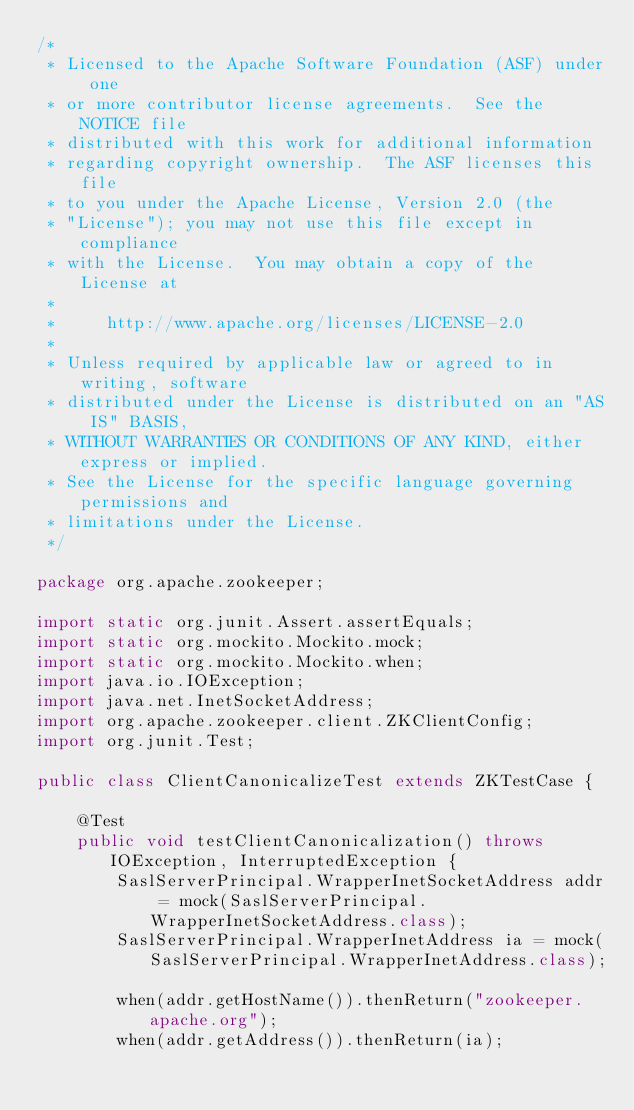Convert code to text. <code><loc_0><loc_0><loc_500><loc_500><_Java_>/*
 * Licensed to the Apache Software Foundation (ASF) under one
 * or more contributor license agreements.  See the NOTICE file
 * distributed with this work for additional information
 * regarding copyright ownership.  The ASF licenses this file
 * to you under the Apache License, Version 2.0 (the
 * "License"); you may not use this file except in compliance
 * with the License.  You may obtain a copy of the License at
 *
 *     http://www.apache.org/licenses/LICENSE-2.0
 *
 * Unless required by applicable law or agreed to in writing, software
 * distributed under the License is distributed on an "AS IS" BASIS,
 * WITHOUT WARRANTIES OR CONDITIONS OF ANY KIND, either express or implied.
 * See the License for the specific language governing permissions and
 * limitations under the License.
 */

package org.apache.zookeeper;

import static org.junit.Assert.assertEquals;
import static org.mockito.Mockito.mock;
import static org.mockito.Mockito.when;
import java.io.IOException;
import java.net.InetSocketAddress;
import org.apache.zookeeper.client.ZKClientConfig;
import org.junit.Test;

public class ClientCanonicalizeTest extends ZKTestCase {

    @Test
    public void testClientCanonicalization() throws IOException, InterruptedException {
        SaslServerPrincipal.WrapperInetSocketAddress addr = mock(SaslServerPrincipal.WrapperInetSocketAddress.class);
        SaslServerPrincipal.WrapperInetAddress ia = mock(SaslServerPrincipal.WrapperInetAddress.class);

        when(addr.getHostName()).thenReturn("zookeeper.apache.org");
        when(addr.getAddress()).thenReturn(ia);</code> 